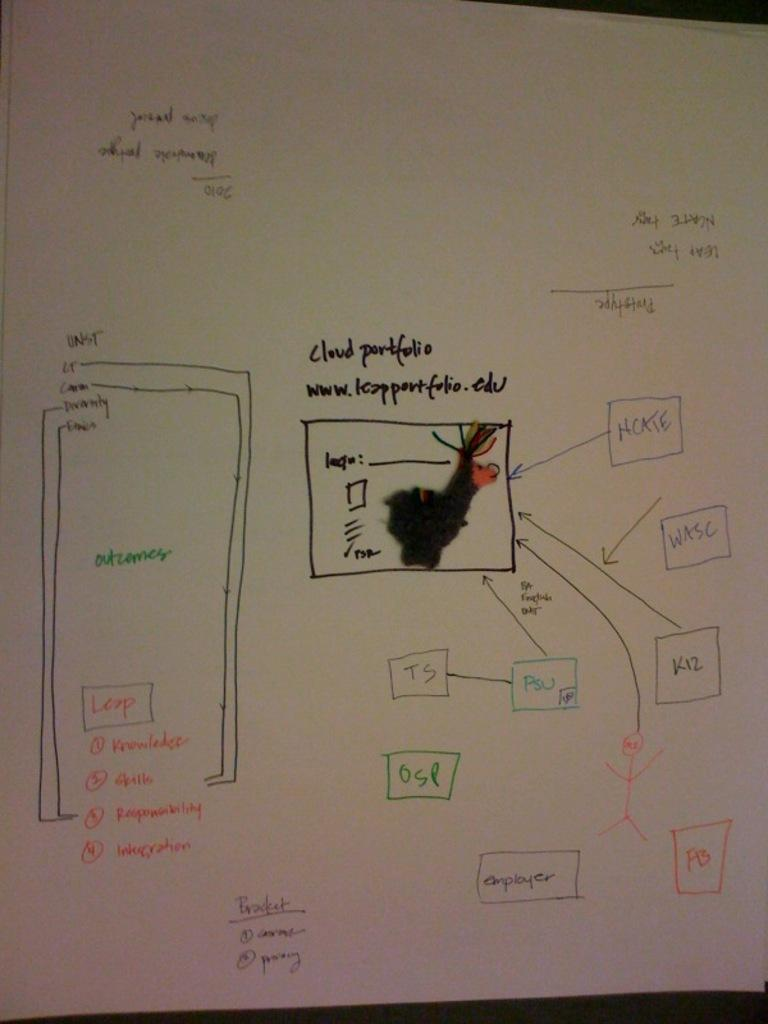What is present on the paper in the image? There is written text on a paper in the image. Can you describe the text in any way? Unfortunately, the specific content of the text cannot be determined from the image alone. Is there anything else visible on the paper besides the text? The provided facts do not mention any additional elements on the paper. What type of card is being pushed by the text in the image? There is no card or pushing action present in the image; it only features written text on a paper. 